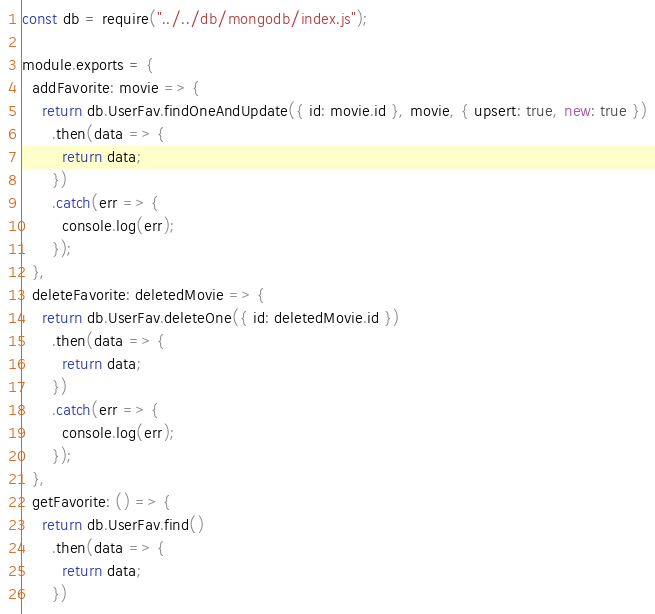Convert code to text. <code><loc_0><loc_0><loc_500><loc_500><_JavaScript_>const db = require("../../db/mongodb/index.js");

module.exports = {
  addFavorite: movie => {
    return db.UserFav.findOneAndUpdate({ id: movie.id }, movie, { upsert: true, new: true })
      .then(data => {
        return data;
      })
      .catch(err => {
        console.log(err);
      });
  },
  deleteFavorite: deletedMovie => {
    return db.UserFav.deleteOne({ id: deletedMovie.id })
      .then(data => {
        return data;
      })
      .catch(err => {
        console.log(err);
      });
  },
  getFavorite: () => {
    return db.UserFav.find()
      .then(data => {
        return data;
      })</code> 